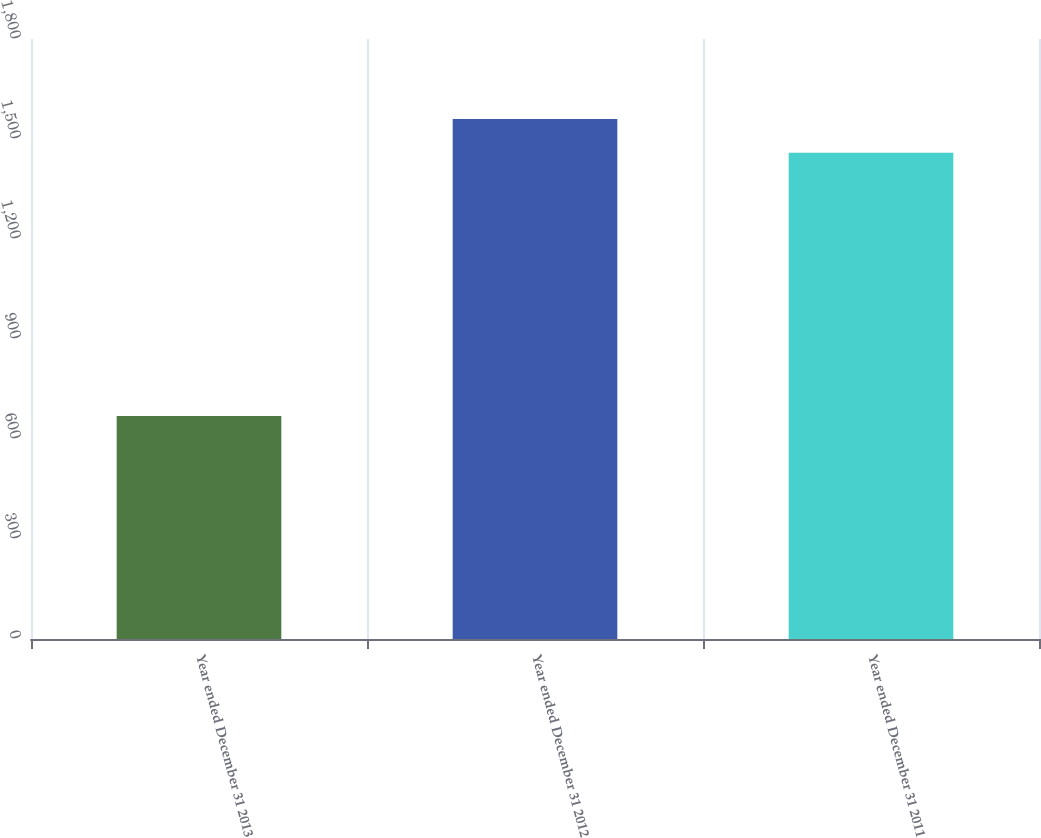Convert chart. <chart><loc_0><loc_0><loc_500><loc_500><bar_chart><fcel>Year ended December 31 2013<fcel>Year ended December 31 2012<fcel>Year ended December 31 2011<nl><fcel>669<fcel>1560<fcel>1459<nl></chart> 